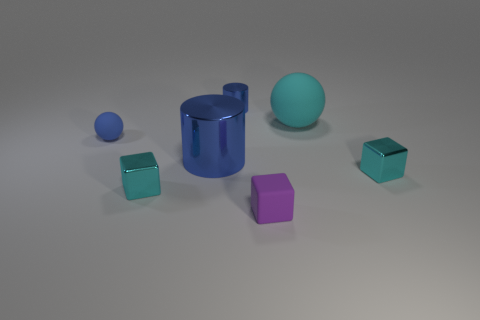There is a tiny thing that is the same color as the small ball; what is its shape?
Offer a very short reply. Cylinder. There is a metal block to the left of the purple rubber block; what size is it?
Provide a short and direct response. Small. Do the purple rubber cube and the sphere to the right of the large blue object have the same size?
Make the answer very short. No. Is the number of blue matte balls that are left of the large blue metal cylinder less than the number of rubber things?
Provide a succinct answer. Yes. What material is the other small thing that is the same shape as the cyan matte object?
Provide a short and direct response. Rubber. There is a tiny object that is right of the large blue metal cylinder and behind the big blue metal thing; what is its shape?
Offer a very short reply. Cylinder. What is the shape of the tiny blue thing that is made of the same material as the big blue cylinder?
Offer a very short reply. Cylinder. There is a block that is on the right side of the tiny purple object; what is it made of?
Make the answer very short. Metal. Is the size of the cylinder that is on the left side of the tiny blue metallic cylinder the same as the cyan block to the left of the small purple thing?
Give a very brief answer. No. The big metallic thing has what color?
Your response must be concise. Blue. 